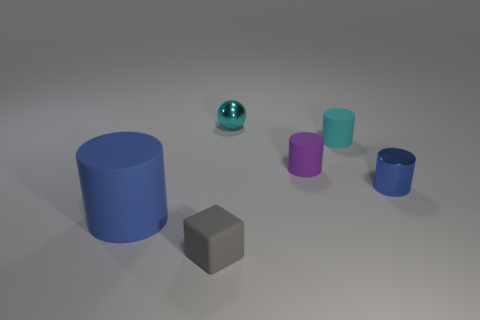Is there any other thing that has the same size as the blue matte thing?
Offer a very short reply. No. Does the cylinder that is on the left side of the cyan sphere have the same color as the tiny shiny cylinder?
Provide a succinct answer. Yes. Is there anything else that has the same shape as the blue rubber thing?
Give a very brief answer. Yes. There is a shiny thing in front of the small metal ball; is there a matte cylinder behind it?
Make the answer very short. Yes. Are there fewer small gray objects to the right of the purple rubber cylinder than small objects that are in front of the large blue object?
Give a very brief answer. Yes. What is the size of the blue cylinder behind the blue thing to the left of the cylinder that is to the right of the cyan cylinder?
Your answer should be compact. Small. Do the blue thing that is on the left side of the block and the small gray block have the same size?
Your answer should be very brief. No. How many other objects are there of the same material as the big blue object?
Your response must be concise. 3. Is the number of large gray metal cylinders greater than the number of tiny blue cylinders?
Your response must be concise. No. There is a blue cylinder that is in front of the blue cylinder on the right side of the matte cylinder on the left side of the small gray block; what is its material?
Offer a very short reply. Rubber. 